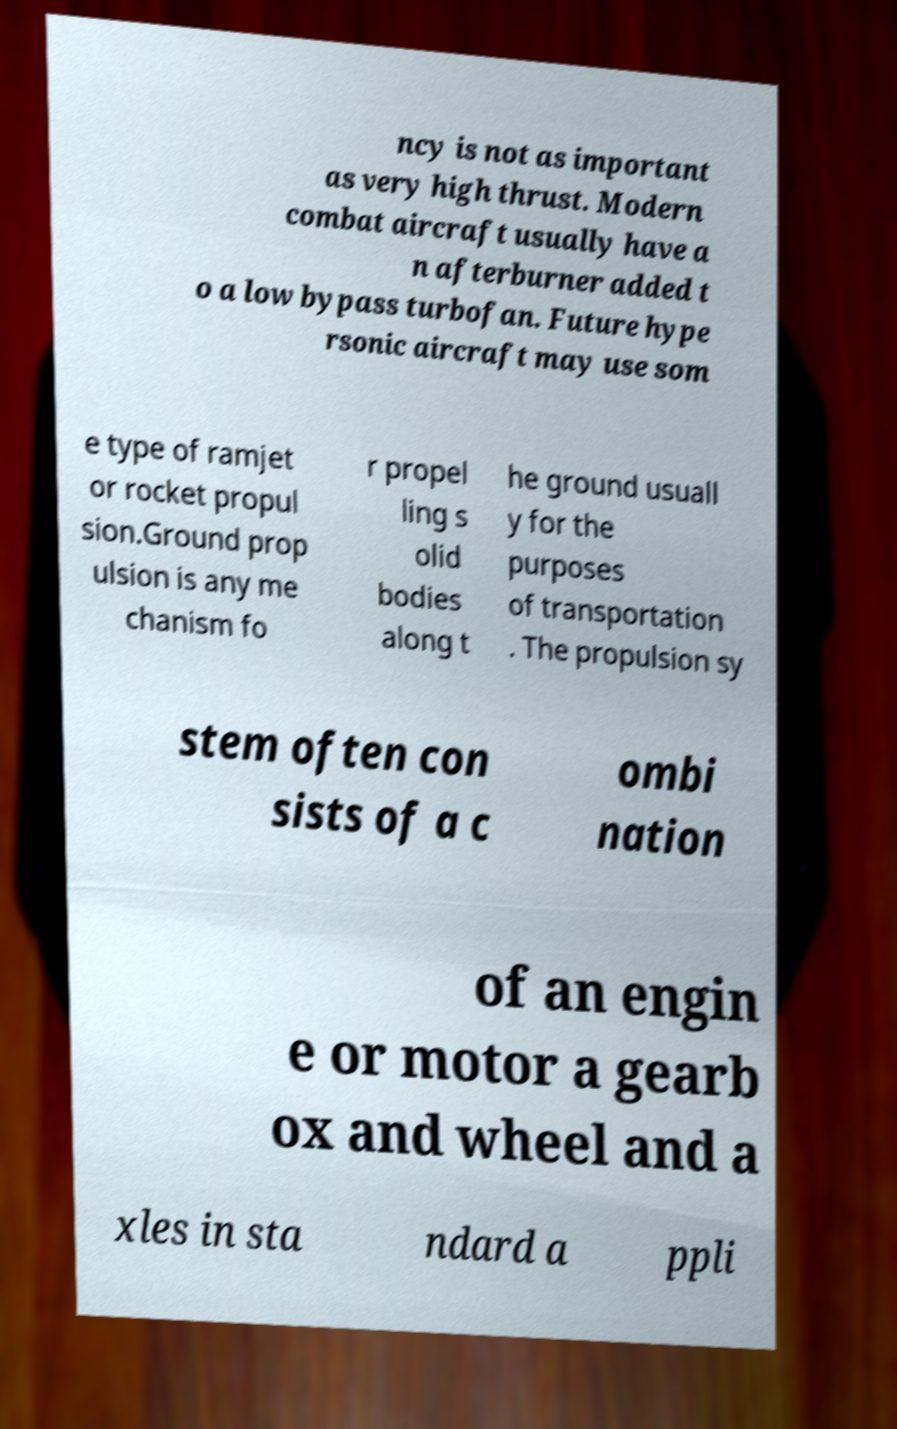For documentation purposes, I need the text within this image transcribed. Could you provide that? ncy is not as important as very high thrust. Modern combat aircraft usually have a n afterburner added t o a low bypass turbofan. Future hype rsonic aircraft may use som e type of ramjet or rocket propul sion.Ground prop ulsion is any me chanism fo r propel ling s olid bodies along t he ground usuall y for the purposes of transportation . The propulsion sy stem often con sists of a c ombi nation of an engin e or motor a gearb ox and wheel and a xles in sta ndard a ppli 